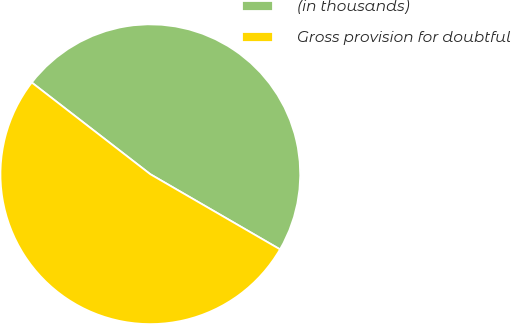Convert chart. <chart><loc_0><loc_0><loc_500><loc_500><pie_chart><fcel>(in thousands)<fcel>Gross provision for doubtful<nl><fcel>47.88%<fcel>52.12%<nl></chart> 